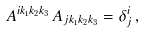Convert formula to latex. <formula><loc_0><loc_0><loc_500><loc_500>A ^ { i k _ { 1 } k _ { 2 } k _ { 3 } } \, A _ { j k _ { 1 } k _ { 2 } k _ { 3 } } = \delta ^ { i } _ { j } \, ,</formula> 